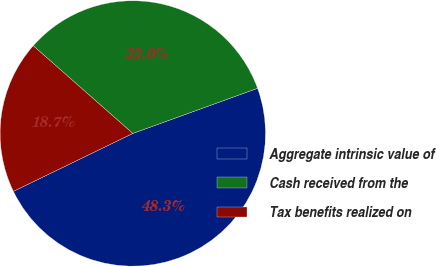Convert chart to OTSL. <chart><loc_0><loc_0><loc_500><loc_500><pie_chart><fcel>Aggregate intrinsic value of<fcel>Cash received from the<fcel>Tax benefits realized on<nl><fcel>48.34%<fcel>32.98%<fcel>18.68%<nl></chart> 